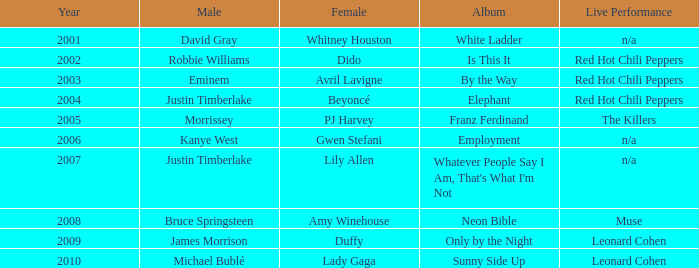Which female artist has an album named elephant? Beyoncé. 